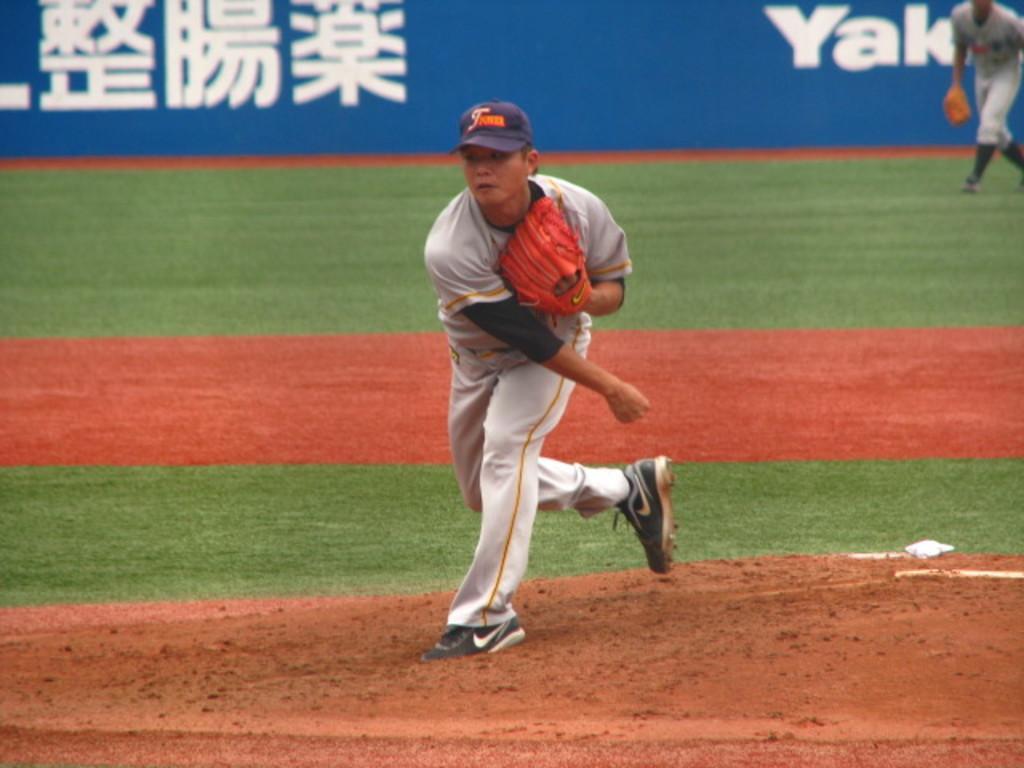Could you give a brief overview of what you see in this image? This picture might be taken inside a playground. In this image, in the middle, we can see a man wearing a blue color hat is running. On the right side, we can see another man walking on the grass, we can also see hoardings which is in blue color, at the bottom, we can see a grass and a land with some stones. 